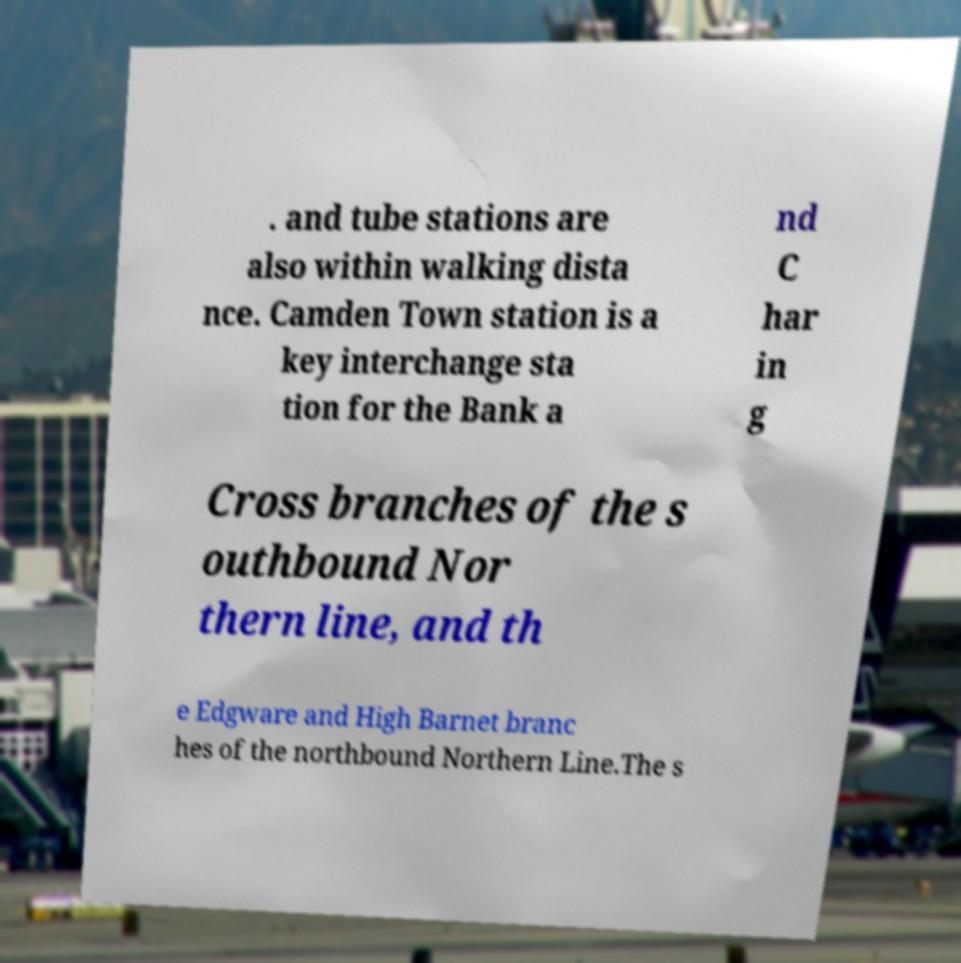Could you extract and type out the text from this image? . and tube stations are also within walking dista nce. Camden Town station is a key interchange sta tion for the Bank a nd C har in g Cross branches of the s outhbound Nor thern line, and th e Edgware and High Barnet branc hes of the northbound Northern Line.The s 